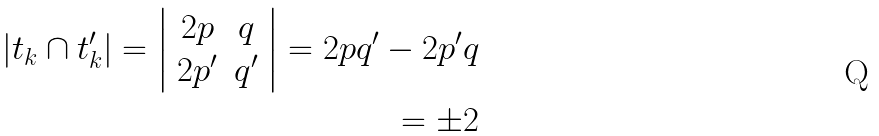<formula> <loc_0><loc_0><loc_500><loc_500>| t _ { k } \cap t _ { k } ^ { \prime } | = \left | \begin{array} { c c } 2 p & q \\ 2 p ^ { \prime } & q ^ { \prime } \\ \end{array} \right | = 2 p q ^ { \prime } - 2 p ^ { \prime } q \\ = \pm 2</formula> 